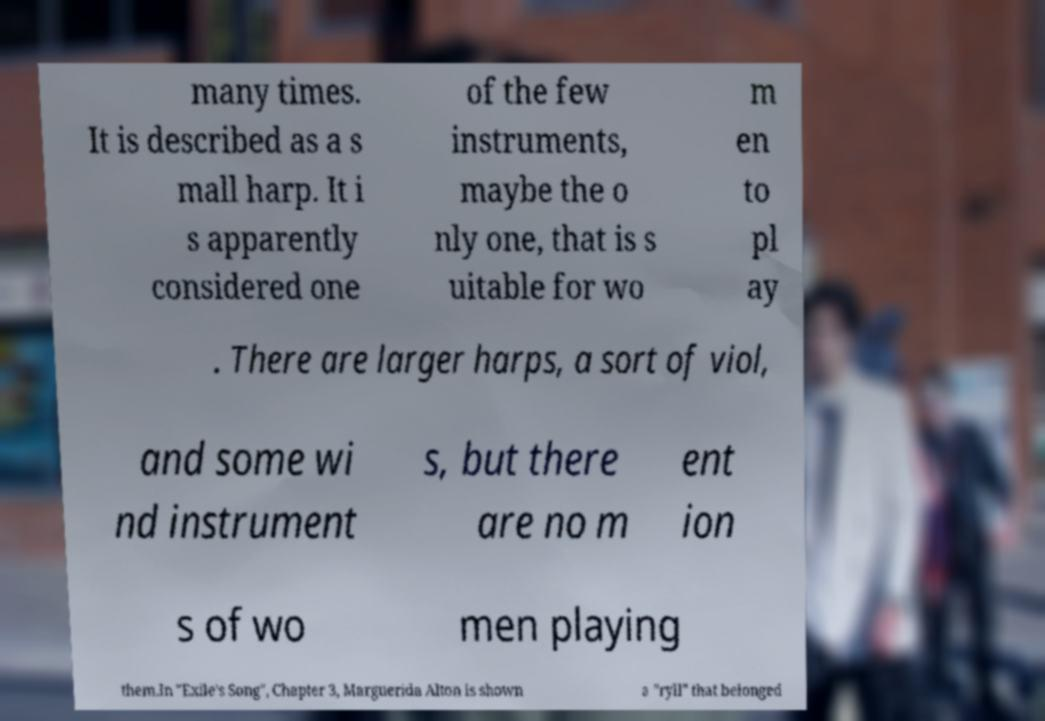I need the written content from this picture converted into text. Can you do that? many times. It is described as a s mall harp. It i s apparently considered one of the few instruments, maybe the o nly one, that is s uitable for wo m en to pl ay . There are larger harps, a sort of viol, and some wi nd instrument s, but there are no m ent ion s of wo men playing them.In "Exile's Song", Chapter 3, Marguerida Alton is shown a "ryll" that belonged 